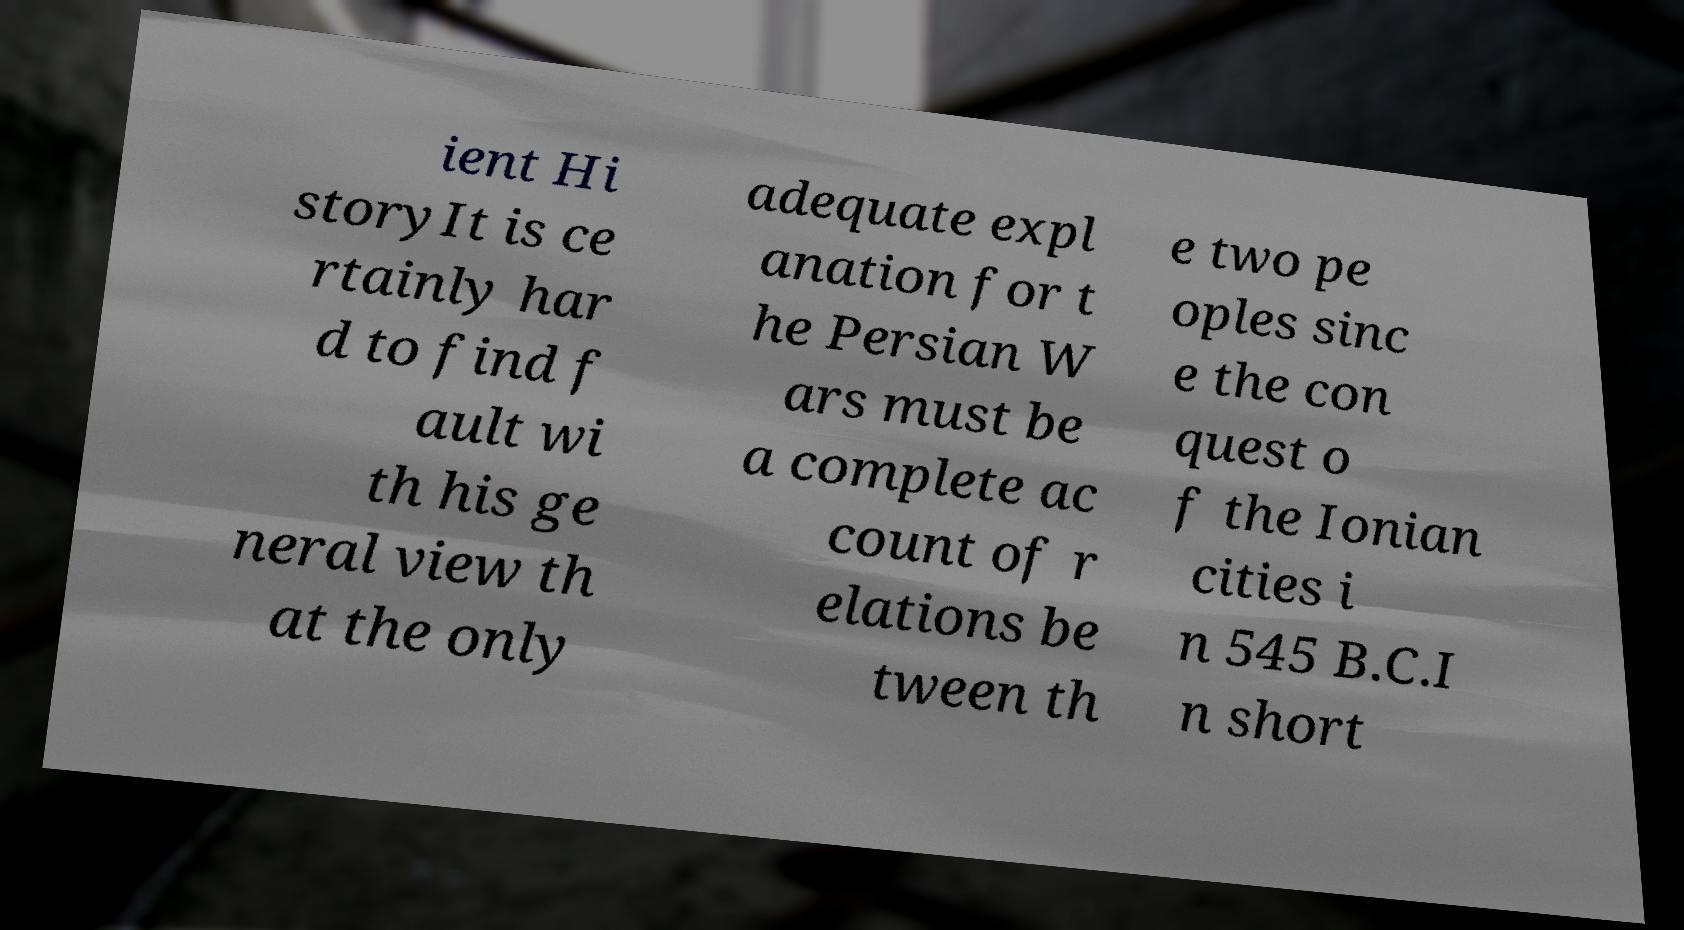For documentation purposes, I need the text within this image transcribed. Could you provide that? ient Hi storyIt is ce rtainly har d to find f ault wi th his ge neral view th at the only adequate expl anation for t he Persian W ars must be a complete ac count of r elations be tween th e two pe oples sinc e the con quest o f the Ionian cities i n 545 B.C.I n short 